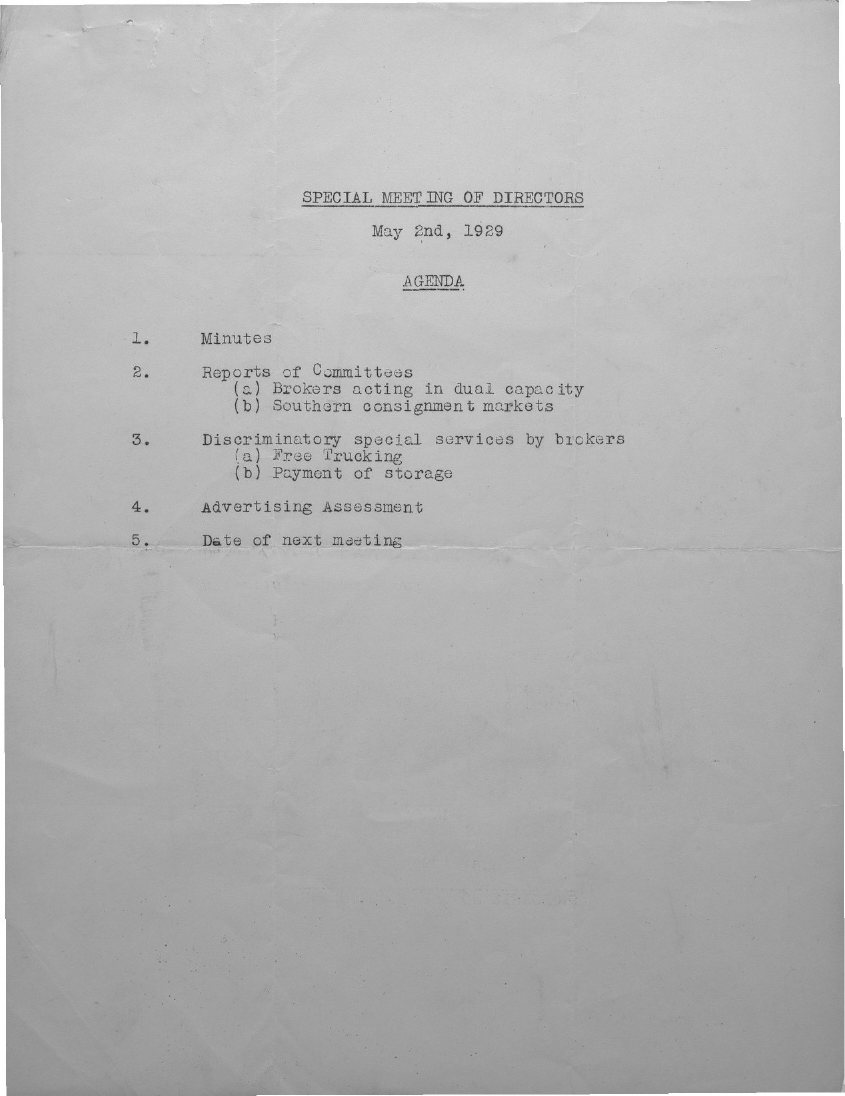When is the special meeting of Directors held?
Your response must be concise. May 2nd, 1929. 